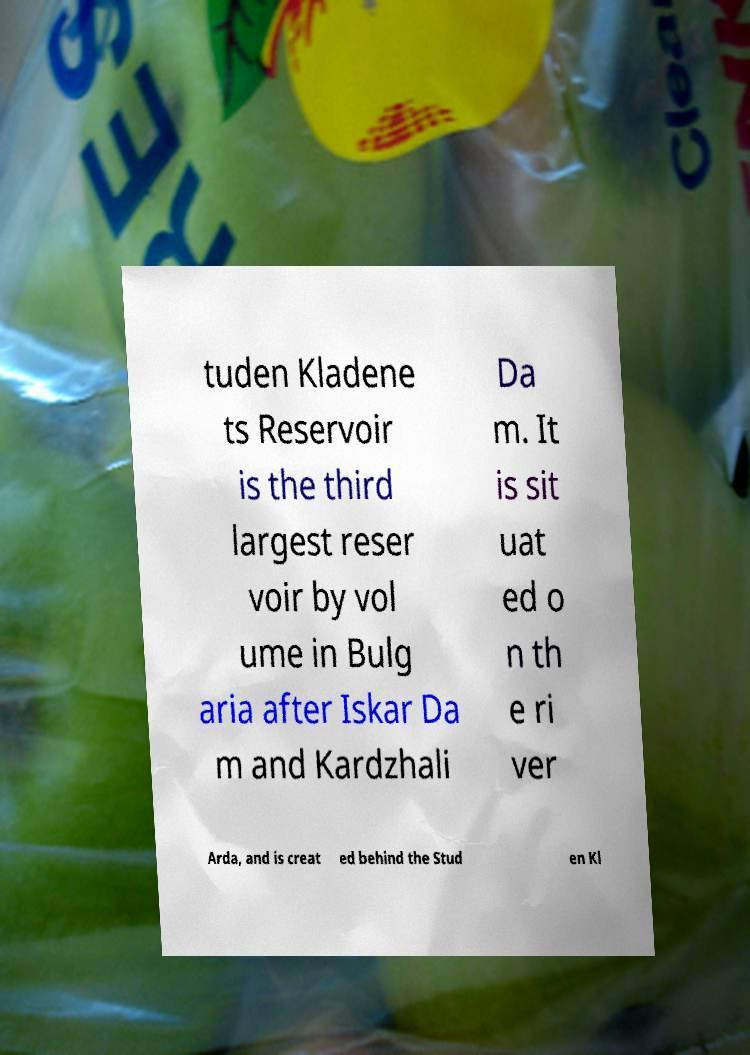There's text embedded in this image that I need extracted. Can you transcribe it verbatim? tuden Kladene ts Reservoir is the third largest reser voir by vol ume in Bulg aria after Iskar Da m and Kardzhali Da m. It is sit uat ed o n th e ri ver Arda, and is creat ed behind the Stud en Kl 